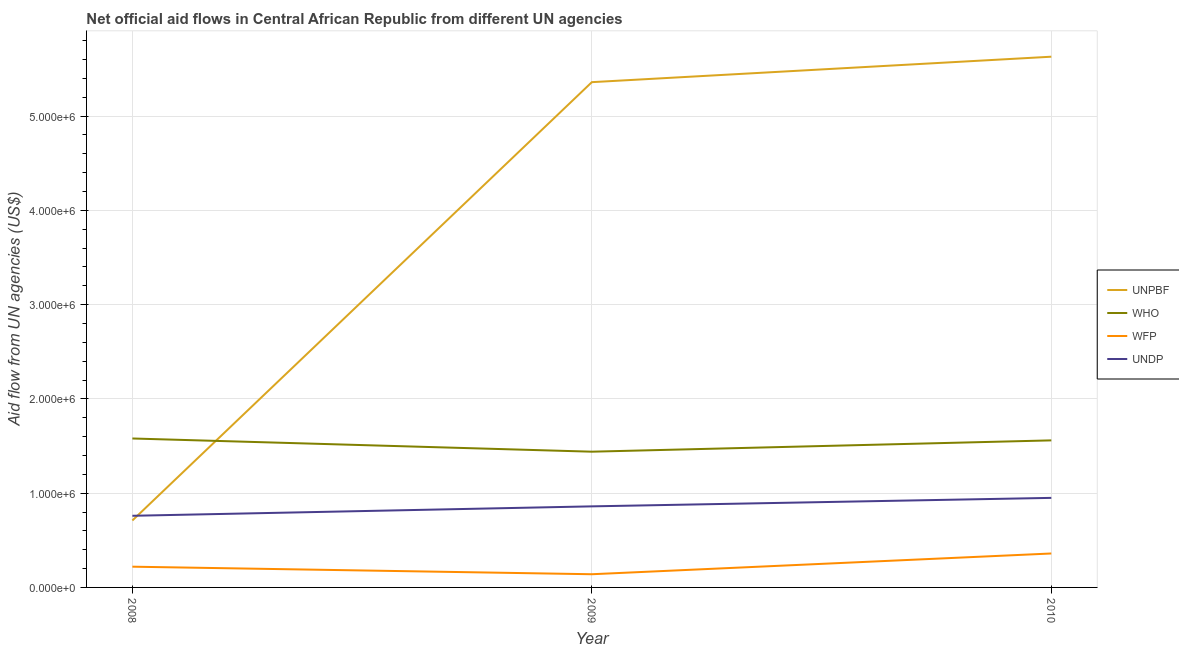Is the number of lines equal to the number of legend labels?
Keep it short and to the point. Yes. What is the amount of aid given by unpbf in 2008?
Provide a short and direct response. 7.10e+05. Across all years, what is the maximum amount of aid given by undp?
Provide a succinct answer. 9.50e+05. Across all years, what is the minimum amount of aid given by wfp?
Offer a very short reply. 1.40e+05. In which year was the amount of aid given by unpbf maximum?
Make the answer very short. 2010. In which year was the amount of aid given by unpbf minimum?
Give a very brief answer. 2008. What is the total amount of aid given by who in the graph?
Offer a very short reply. 4.58e+06. What is the difference between the amount of aid given by who in 2009 and that in 2010?
Offer a very short reply. -1.20e+05. What is the difference between the amount of aid given by wfp in 2010 and the amount of aid given by undp in 2008?
Give a very brief answer. -4.00e+05. What is the average amount of aid given by unpbf per year?
Offer a very short reply. 3.90e+06. In the year 2009, what is the difference between the amount of aid given by who and amount of aid given by unpbf?
Keep it short and to the point. -3.92e+06. In how many years, is the amount of aid given by wfp greater than 4000000 US$?
Your answer should be very brief. 0. What is the ratio of the amount of aid given by undp in 2009 to that in 2010?
Your response must be concise. 0.91. Is the difference between the amount of aid given by who in 2009 and 2010 greater than the difference between the amount of aid given by wfp in 2009 and 2010?
Make the answer very short. Yes. What is the difference between the highest and the lowest amount of aid given by undp?
Your answer should be compact. 1.90e+05. Is the sum of the amount of aid given by unpbf in 2008 and 2010 greater than the maximum amount of aid given by undp across all years?
Your answer should be compact. Yes. Is it the case that in every year, the sum of the amount of aid given by unpbf and amount of aid given by who is greater than the sum of amount of aid given by undp and amount of aid given by wfp?
Your answer should be very brief. Yes. Does the amount of aid given by undp monotonically increase over the years?
Your response must be concise. Yes. Are the values on the major ticks of Y-axis written in scientific E-notation?
Your answer should be compact. Yes. Does the graph contain grids?
Your answer should be very brief. Yes. Where does the legend appear in the graph?
Offer a very short reply. Center right. How many legend labels are there?
Ensure brevity in your answer.  4. How are the legend labels stacked?
Give a very brief answer. Vertical. What is the title of the graph?
Your response must be concise. Net official aid flows in Central African Republic from different UN agencies. Does "Labor Taxes" appear as one of the legend labels in the graph?
Provide a short and direct response. No. What is the label or title of the Y-axis?
Ensure brevity in your answer.  Aid flow from UN agencies (US$). What is the Aid flow from UN agencies (US$) in UNPBF in 2008?
Your response must be concise. 7.10e+05. What is the Aid flow from UN agencies (US$) of WHO in 2008?
Offer a terse response. 1.58e+06. What is the Aid flow from UN agencies (US$) of WFP in 2008?
Give a very brief answer. 2.20e+05. What is the Aid flow from UN agencies (US$) of UNDP in 2008?
Your answer should be compact. 7.60e+05. What is the Aid flow from UN agencies (US$) in UNPBF in 2009?
Your answer should be compact. 5.36e+06. What is the Aid flow from UN agencies (US$) in WHO in 2009?
Offer a terse response. 1.44e+06. What is the Aid flow from UN agencies (US$) of WFP in 2009?
Offer a terse response. 1.40e+05. What is the Aid flow from UN agencies (US$) in UNDP in 2009?
Keep it short and to the point. 8.60e+05. What is the Aid flow from UN agencies (US$) of UNPBF in 2010?
Provide a succinct answer. 5.63e+06. What is the Aid flow from UN agencies (US$) in WHO in 2010?
Make the answer very short. 1.56e+06. What is the Aid flow from UN agencies (US$) of WFP in 2010?
Provide a succinct answer. 3.60e+05. What is the Aid flow from UN agencies (US$) in UNDP in 2010?
Offer a terse response. 9.50e+05. Across all years, what is the maximum Aid flow from UN agencies (US$) of UNPBF?
Keep it short and to the point. 5.63e+06. Across all years, what is the maximum Aid flow from UN agencies (US$) of WHO?
Ensure brevity in your answer.  1.58e+06. Across all years, what is the maximum Aid flow from UN agencies (US$) of WFP?
Offer a very short reply. 3.60e+05. Across all years, what is the maximum Aid flow from UN agencies (US$) in UNDP?
Your response must be concise. 9.50e+05. Across all years, what is the minimum Aid flow from UN agencies (US$) in UNPBF?
Your answer should be compact. 7.10e+05. Across all years, what is the minimum Aid flow from UN agencies (US$) in WHO?
Provide a short and direct response. 1.44e+06. Across all years, what is the minimum Aid flow from UN agencies (US$) of WFP?
Make the answer very short. 1.40e+05. Across all years, what is the minimum Aid flow from UN agencies (US$) of UNDP?
Ensure brevity in your answer.  7.60e+05. What is the total Aid flow from UN agencies (US$) in UNPBF in the graph?
Your answer should be very brief. 1.17e+07. What is the total Aid flow from UN agencies (US$) of WHO in the graph?
Offer a very short reply. 4.58e+06. What is the total Aid flow from UN agencies (US$) in WFP in the graph?
Make the answer very short. 7.20e+05. What is the total Aid flow from UN agencies (US$) of UNDP in the graph?
Ensure brevity in your answer.  2.57e+06. What is the difference between the Aid flow from UN agencies (US$) in UNPBF in 2008 and that in 2009?
Offer a terse response. -4.65e+06. What is the difference between the Aid flow from UN agencies (US$) in WFP in 2008 and that in 2009?
Provide a short and direct response. 8.00e+04. What is the difference between the Aid flow from UN agencies (US$) in UNPBF in 2008 and that in 2010?
Provide a short and direct response. -4.92e+06. What is the difference between the Aid flow from UN agencies (US$) of WFP in 2008 and that in 2010?
Keep it short and to the point. -1.40e+05. What is the difference between the Aid flow from UN agencies (US$) in UNDP in 2008 and that in 2010?
Make the answer very short. -1.90e+05. What is the difference between the Aid flow from UN agencies (US$) of WHO in 2009 and that in 2010?
Ensure brevity in your answer.  -1.20e+05. What is the difference between the Aid flow from UN agencies (US$) of WFP in 2009 and that in 2010?
Your answer should be compact. -2.20e+05. What is the difference between the Aid flow from UN agencies (US$) of UNPBF in 2008 and the Aid flow from UN agencies (US$) of WHO in 2009?
Your answer should be very brief. -7.30e+05. What is the difference between the Aid flow from UN agencies (US$) of UNPBF in 2008 and the Aid flow from UN agencies (US$) of WFP in 2009?
Offer a terse response. 5.70e+05. What is the difference between the Aid flow from UN agencies (US$) in WHO in 2008 and the Aid flow from UN agencies (US$) in WFP in 2009?
Offer a very short reply. 1.44e+06. What is the difference between the Aid flow from UN agencies (US$) of WHO in 2008 and the Aid flow from UN agencies (US$) of UNDP in 2009?
Offer a terse response. 7.20e+05. What is the difference between the Aid flow from UN agencies (US$) of WFP in 2008 and the Aid flow from UN agencies (US$) of UNDP in 2009?
Provide a succinct answer. -6.40e+05. What is the difference between the Aid flow from UN agencies (US$) of UNPBF in 2008 and the Aid flow from UN agencies (US$) of WHO in 2010?
Make the answer very short. -8.50e+05. What is the difference between the Aid flow from UN agencies (US$) in UNPBF in 2008 and the Aid flow from UN agencies (US$) in UNDP in 2010?
Give a very brief answer. -2.40e+05. What is the difference between the Aid flow from UN agencies (US$) of WHO in 2008 and the Aid flow from UN agencies (US$) of WFP in 2010?
Provide a succinct answer. 1.22e+06. What is the difference between the Aid flow from UN agencies (US$) of WHO in 2008 and the Aid flow from UN agencies (US$) of UNDP in 2010?
Your answer should be compact. 6.30e+05. What is the difference between the Aid flow from UN agencies (US$) of WFP in 2008 and the Aid flow from UN agencies (US$) of UNDP in 2010?
Your response must be concise. -7.30e+05. What is the difference between the Aid flow from UN agencies (US$) in UNPBF in 2009 and the Aid flow from UN agencies (US$) in WHO in 2010?
Keep it short and to the point. 3.80e+06. What is the difference between the Aid flow from UN agencies (US$) of UNPBF in 2009 and the Aid flow from UN agencies (US$) of UNDP in 2010?
Your answer should be very brief. 4.41e+06. What is the difference between the Aid flow from UN agencies (US$) of WHO in 2009 and the Aid flow from UN agencies (US$) of WFP in 2010?
Provide a succinct answer. 1.08e+06. What is the difference between the Aid flow from UN agencies (US$) of WHO in 2009 and the Aid flow from UN agencies (US$) of UNDP in 2010?
Your answer should be very brief. 4.90e+05. What is the difference between the Aid flow from UN agencies (US$) of WFP in 2009 and the Aid flow from UN agencies (US$) of UNDP in 2010?
Ensure brevity in your answer.  -8.10e+05. What is the average Aid flow from UN agencies (US$) of UNPBF per year?
Ensure brevity in your answer.  3.90e+06. What is the average Aid flow from UN agencies (US$) in WHO per year?
Provide a succinct answer. 1.53e+06. What is the average Aid flow from UN agencies (US$) in WFP per year?
Offer a terse response. 2.40e+05. What is the average Aid flow from UN agencies (US$) of UNDP per year?
Your answer should be very brief. 8.57e+05. In the year 2008, what is the difference between the Aid flow from UN agencies (US$) in UNPBF and Aid flow from UN agencies (US$) in WHO?
Your response must be concise. -8.70e+05. In the year 2008, what is the difference between the Aid flow from UN agencies (US$) of UNPBF and Aid flow from UN agencies (US$) of WFP?
Provide a short and direct response. 4.90e+05. In the year 2008, what is the difference between the Aid flow from UN agencies (US$) of WHO and Aid flow from UN agencies (US$) of WFP?
Keep it short and to the point. 1.36e+06. In the year 2008, what is the difference between the Aid flow from UN agencies (US$) in WHO and Aid flow from UN agencies (US$) in UNDP?
Keep it short and to the point. 8.20e+05. In the year 2008, what is the difference between the Aid flow from UN agencies (US$) in WFP and Aid flow from UN agencies (US$) in UNDP?
Your answer should be compact. -5.40e+05. In the year 2009, what is the difference between the Aid flow from UN agencies (US$) of UNPBF and Aid flow from UN agencies (US$) of WHO?
Provide a short and direct response. 3.92e+06. In the year 2009, what is the difference between the Aid flow from UN agencies (US$) in UNPBF and Aid flow from UN agencies (US$) in WFP?
Offer a very short reply. 5.22e+06. In the year 2009, what is the difference between the Aid flow from UN agencies (US$) in UNPBF and Aid flow from UN agencies (US$) in UNDP?
Give a very brief answer. 4.50e+06. In the year 2009, what is the difference between the Aid flow from UN agencies (US$) in WHO and Aid flow from UN agencies (US$) in WFP?
Your answer should be very brief. 1.30e+06. In the year 2009, what is the difference between the Aid flow from UN agencies (US$) in WHO and Aid flow from UN agencies (US$) in UNDP?
Offer a very short reply. 5.80e+05. In the year 2009, what is the difference between the Aid flow from UN agencies (US$) in WFP and Aid flow from UN agencies (US$) in UNDP?
Your answer should be compact. -7.20e+05. In the year 2010, what is the difference between the Aid flow from UN agencies (US$) of UNPBF and Aid flow from UN agencies (US$) of WHO?
Your answer should be very brief. 4.07e+06. In the year 2010, what is the difference between the Aid flow from UN agencies (US$) of UNPBF and Aid flow from UN agencies (US$) of WFP?
Offer a very short reply. 5.27e+06. In the year 2010, what is the difference between the Aid flow from UN agencies (US$) of UNPBF and Aid flow from UN agencies (US$) of UNDP?
Keep it short and to the point. 4.68e+06. In the year 2010, what is the difference between the Aid flow from UN agencies (US$) in WHO and Aid flow from UN agencies (US$) in WFP?
Offer a very short reply. 1.20e+06. In the year 2010, what is the difference between the Aid flow from UN agencies (US$) in WHO and Aid flow from UN agencies (US$) in UNDP?
Keep it short and to the point. 6.10e+05. In the year 2010, what is the difference between the Aid flow from UN agencies (US$) in WFP and Aid flow from UN agencies (US$) in UNDP?
Your answer should be very brief. -5.90e+05. What is the ratio of the Aid flow from UN agencies (US$) in UNPBF in 2008 to that in 2009?
Make the answer very short. 0.13. What is the ratio of the Aid flow from UN agencies (US$) of WHO in 2008 to that in 2009?
Your answer should be very brief. 1.1. What is the ratio of the Aid flow from UN agencies (US$) in WFP in 2008 to that in 2009?
Keep it short and to the point. 1.57. What is the ratio of the Aid flow from UN agencies (US$) in UNDP in 2008 to that in 2009?
Ensure brevity in your answer.  0.88. What is the ratio of the Aid flow from UN agencies (US$) of UNPBF in 2008 to that in 2010?
Your answer should be compact. 0.13. What is the ratio of the Aid flow from UN agencies (US$) of WHO in 2008 to that in 2010?
Give a very brief answer. 1.01. What is the ratio of the Aid flow from UN agencies (US$) in WFP in 2008 to that in 2010?
Ensure brevity in your answer.  0.61. What is the ratio of the Aid flow from UN agencies (US$) of UNDP in 2008 to that in 2010?
Keep it short and to the point. 0.8. What is the ratio of the Aid flow from UN agencies (US$) of WHO in 2009 to that in 2010?
Your response must be concise. 0.92. What is the ratio of the Aid flow from UN agencies (US$) of WFP in 2009 to that in 2010?
Provide a short and direct response. 0.39. What is the ratio of the Aid flow from UN agencies (US$) in UNDP in 2009 to that in 2010?
Provide a short and direct response. 0.91. What is the difference between the highest and the second highest Aid flow from UN agencies (US$) of UNDP?
Provide a succinct answer. 9.00e+04. What is the difference between the highest and the lowest Aid flow from UN agencies (US$) of UNPBF?
Provide a succinct answer. 4.92e+06. What is the difference between the highest and the lowest Aid flow from UN agencies (US$) in WFP?
Offer a very short reply. 2.20e+05. 